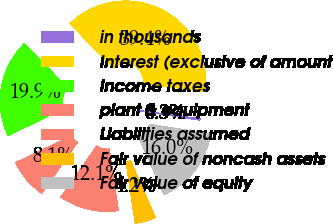<chart> <loc_0><loc_0><loc_500><loc_500><pie_chart><fcel>in thousands<fcel>Interest (exclusive of amount<fcel>Income taxes<fcel>plant & equipment<fcel>Liabilities assumed<fcel>Fair value of noncash assets<fcel>Fair value of equity<nl><fcel>0.33%<fcel>39.41%<fcel>19.87%<fcel>8.14%<fcel>12.05%<fcel>4.24%<fcel>15.96%<nl></chart> 